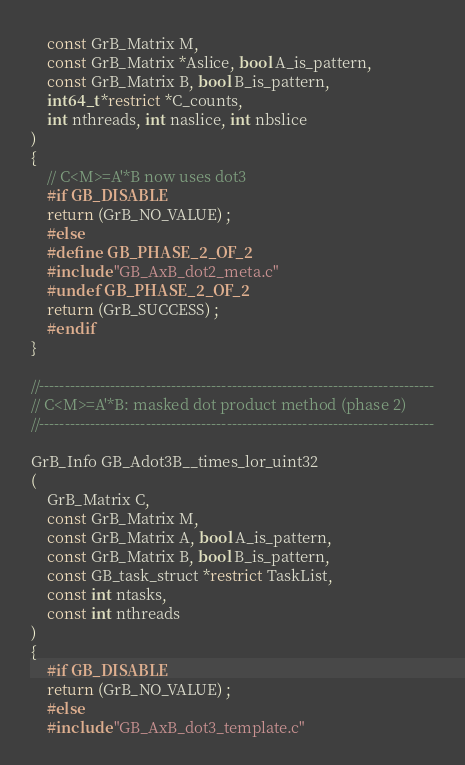<code> <loc_0><loc_0><loc_500><loc_500><_C_>    const GrB_Matrix M,
    const GrB_Matrix *Aslice, bool A_is_pattern,
    const GrB_Matrix B, bool B_is_pattern,
    int64_t *restrict *C_counts,
    int nthreads, int naslice, int nbslice
)
{ 
    // C<M>=A'*B now uses dot3
    #if GB_DISABLE
    return (GrB_NO_VALUE) ;
    #else
    #define GB_PHASE_2_OF_2
    #include "GB_AxB_dot2_meta.c"
    #undef GB_PHASE_2_OF_2
    return (GrB_SUCCESS) ;
    #endif
}

//------------------------------------------------------------------------------
// C<M>=A'*B: masked dot product method (phase 2)
//------------------------------------------------------------------------------

GrB_Info GB_Adot3B__times_lor_uint32
(
    GrB_Matrix C,
    const GrB_Matrix M,
    const GrB_Matrix A, bool A_is_pattern,
    const GrB_Matrix B, bool B_is_pattern,
    const GB_task_struct *restrict TaskList,
    const int ntasks,
    const int nthreads
)
{ 
    #if GB_DISABLE
    return (GrB_NO_VALUE) ;
    #else
    #include "GB_AxB_dot3_template.c"</code> 